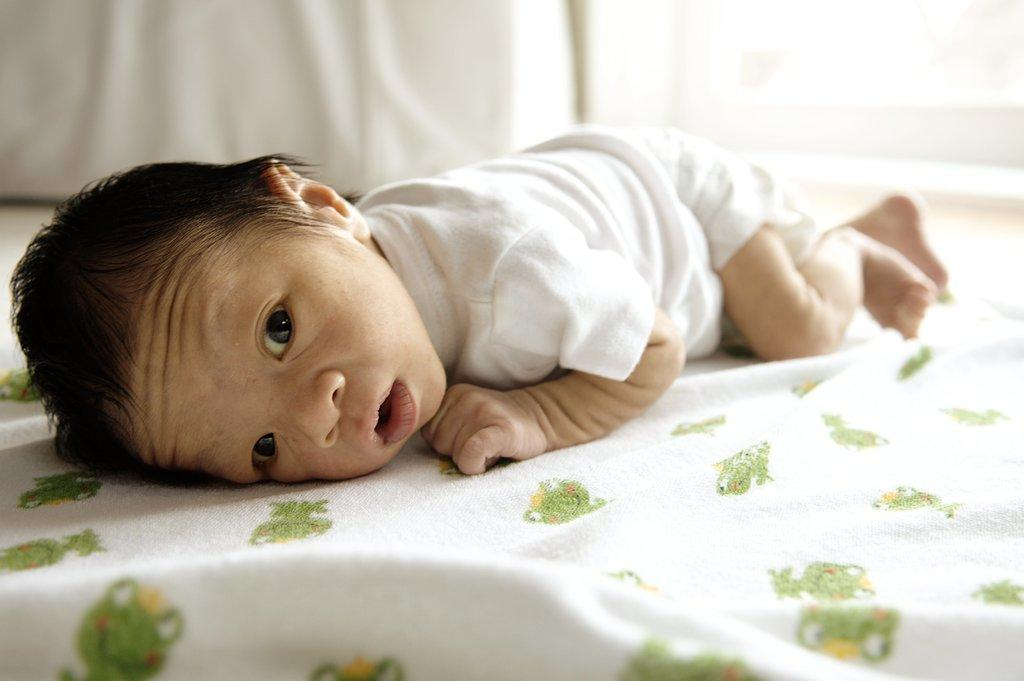What is the main subject of the picture? The main subject of the picture is a small baby. Where is the baby located in the image? The baby is sleeping on a bed. What is covering the baby in the image? There is a blanket on the bed. Can you describe the design of the blanket? The blanket has a green design. What type of credit does the baby have in the image? There is no mention of credit in the image. --- Facts: 1. There is a person in the image. 2. The person is wearing a hat. 3. The hat has a red band. 4. The person is holding a book. Absurd Topics: dinosaur, volcano Conversation: Who or what is the main subject in the image? The main subject in the image is a person. What is the person wearing in the image? The person is wearing a hat. Can you describe the hat in the image? The hat has a red band. What is the person holding in the image? The person is holding a book. Reasoning: Let's think step by step in order to create the conversation. We start by identifying the main subject of the image, which is a person. Then, we describe the person's attire, which is a hat. Next, we provide a description of the hat, which is that it has a red band. Finally, we mention what the person is holding, which is a book. Absurd Question/Answer: Can you see a dinosaur or a volcano in the image? There is no dinosaur or volcano present in the image. --- Facts: 1. There is a group of people in the image. 2. The people are sitting around a table. 3. There is a plate of food on the table. 4. The food on the plate is pizza. Absurd Topics: unicorn, rainbow Conversation: How many people are in the image? There is a group of people in the image. What are the people doing in the image? The people are sitting around a table. What is on the table in the image? There is a plate of food on the table. What type of food is on the plate in the image? The food on the plate is pizza. Reasoning: Let's think step by step in order to create the conversation. We start by identifying the main subject of the image, which is a group of people. Then, we describe the people's actions, which is that they are sitting around a table. Next, we provide a description of the food on the plate, which is that it is pizza. Absurd Question/Answer: Can you see a unicorn or a rainbow in the image? There is no unicorn or rainbow present in the image. 